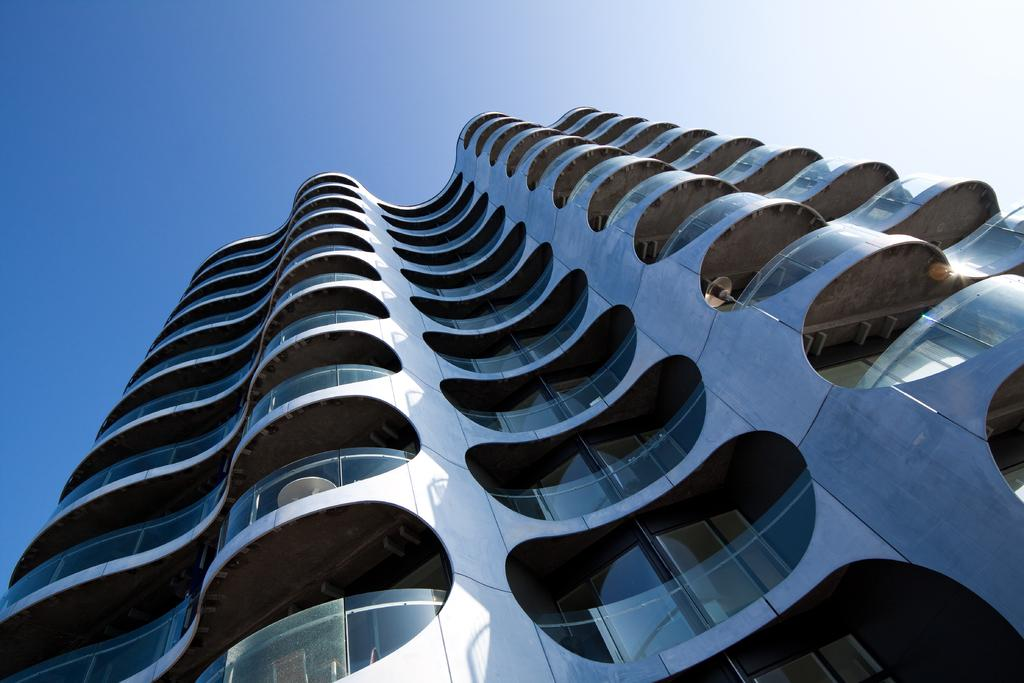What type of structure is present in the image? There is a multistory building in the image. How is the building positioned in the image? The building is rotated in a right angle. What can be seen at the top of the image? The sky is visible at the top of the image. What theory is being proposed in the image? There is no theory or statement being proposed in the image; it simply features a multistory building with a right-angle rotation. Can you see a lake in the image? There is no lake present in the image. 